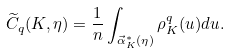<formula> <loc_0><loc_0><loc_500><loc_500>\widetilde { C } _ { q } ( K , \eta ) = \frac { 1 } { n } \int _ { \vec { \alpha } _ { K } ^ { * } ( \eta ) } \rho _ { K } ^ { q } ( u ) d u .</formula> 